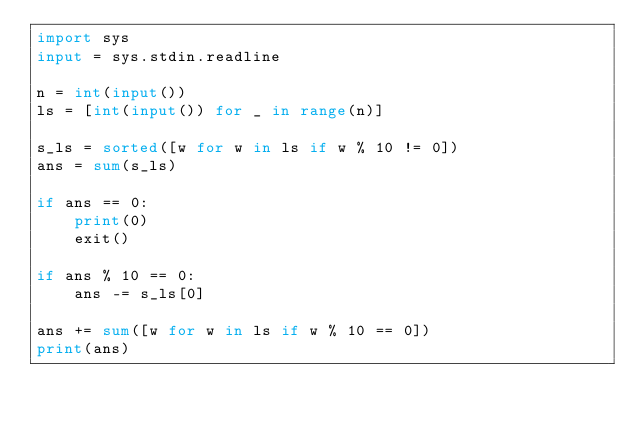<code> <loc_0><loc_0><loc_500><loc_500><_Python_>import sys
input = sys.stdin.readline

n = int(input())
ls = [int(input()) for _ in range(n)]

s_ls = sorted([w for w in ls if w % 10 != 0])
ans = sum(s_ls)

if ans == 0:
    print(0)
    exit()

if ans % 10 == 0:
    ans -= s_ls[0]

ans += sum([w for w in ls if w % 10 == 0])
print(ans)
</code> 